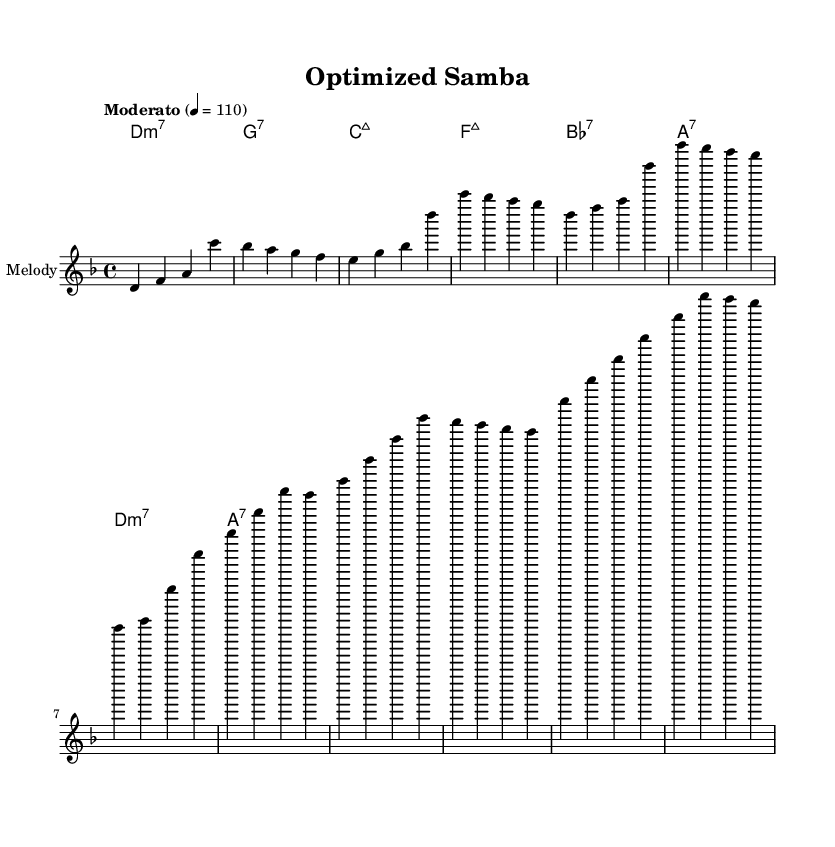What is the key signature of this music? The key signature is D minor, which has one flat (B flat). This is determined by the key indicated in the global information section of the code, where it specifies "d \minor".
Answer: D minor What is the time signature of this music? The time signature is 4/4, as indicated in the global section of the code with "\time 4/4". This means there are four beats in each measure.
Answer: 4/4 What is the tempo marking for this piece? The tempo marking is "Moderato" with a tempo of 110 beats per minute, specified in the global section as "\tempo". This indicates a moderate speed for the performance.
Answer: Moderato How many measures are in the chorus section? The chorus section consists of four measures, which can be counted from the melody in the provided code under the comment labeled "% Chorus". Each line corresponds to a measure.
Answer: 4 What type of seventh chord is primarily used in the harmony? The harmony section features primarily seventh chords, particularly a mix of minor and major, as noted in the chord mode. The specific chords include D minor 7, G dominant 7, C major 7, and others, but they all belong to the category of seventh chords.
Answer: Seventh chords What is the last note of the melody in the written score? The last note of the melody is "a", shown on the final beat of the last measure of the melody section. This can be identified by locating the melody notes as structured in their respective sections.
Answer: a Which rhythmic feel is characteristic of this Latin jazz piece? The rhythmic feel in this Latin jazz piece is characterized by a syncopated rhythm commonly found in samba, as suggested by the "Samba" title and the syncopation that arises from the phrasing of the melody and the emphasis in the accompaniment.
Answer: Samba 